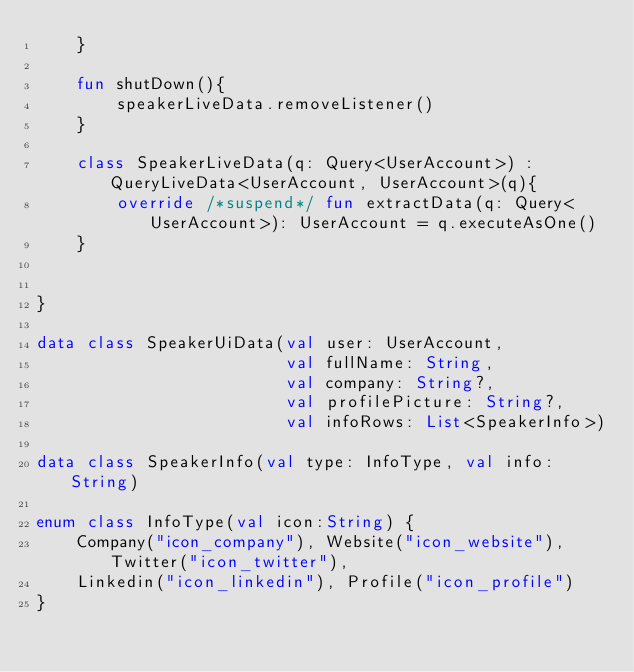Convert code to text. <code><loc_0><loc_0><loc_500><loc_500><_Kotlin_>    }

    fun shutDown(){
        speakerLiveData.removeListener()
    }

    class SpeakerLiveData(q: Query<UserAccount>) : QueryLiveData<UserAccount, UserAccount>(q){
        override /*suspend*/ fun extractData(q: Query<UserAccount>): UserAccount = q.executeAsOne()
    }


}

data class SpeakerUiData(val user: UserAccount,
                         val fullName: String,
                         val company: String?,
                         val profilePicture: String?,
                         val infoRows: List<SpeakerInfo>)

data class SpeakerInfo(val type: InfoType, val info:String)

enum class InfoType(val icon:String) {
    Company("icon_company"), Website("icon_website"), Twitter("icon_twitter"),
    Linkedin("icon_linkedin"), Profile("icon_profile")
}</code> 